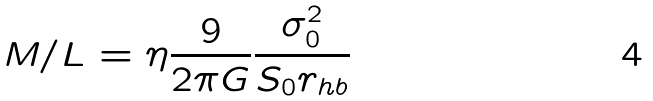<formula> <loc_0><loc_0><loc_500><loc_500>M / L = \eta \frac { 9 } { 2 \pi G } \frac { \sigma _ { 0 } ^ { 2 } } { S _ { 0 } r _ { h b } }</formula> 